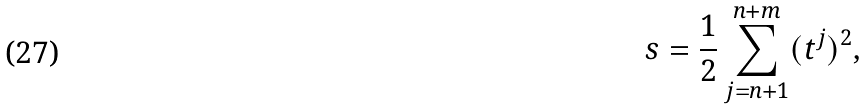<formula> <loc_0><loc_0><loc_500><loc_500>s = \frac { 1 } { 2 } \sum _ { j = n + 1 } ^ { n + m } ( t ^ { j } ) ^ { 2 } ,</formula> 